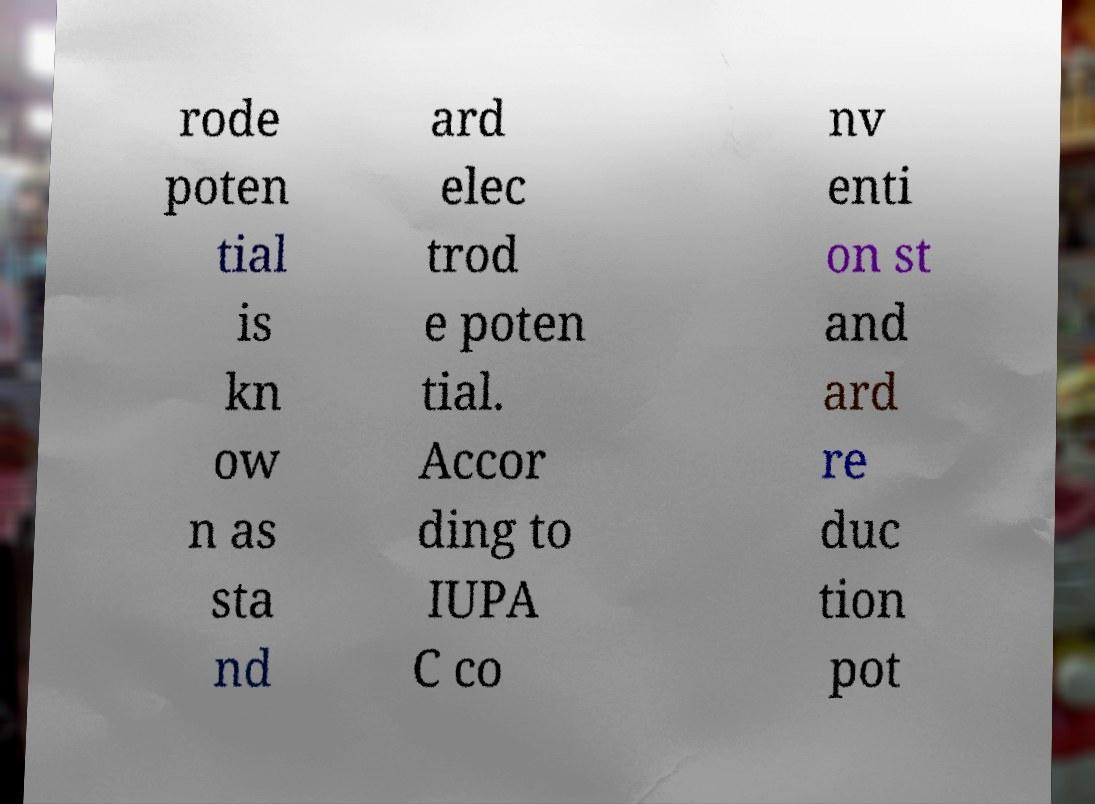Could you extract and type out the text from this image? rode poten tial is kn ow n as sta nd ard elec trod e poten tial. Accor ding to IUPA C co nv enti on st and ard re duc tion pot 